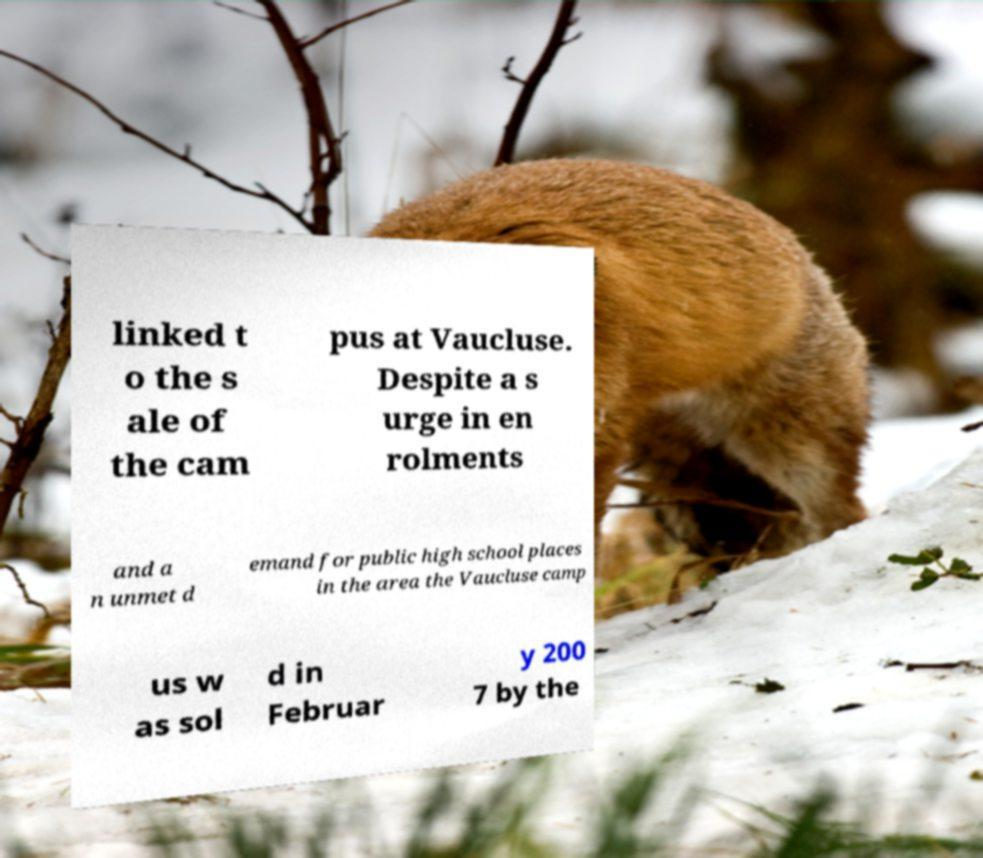Could you extract and type out the text from this image? linked t o the s ale of the cam pus at Vaucluse. Despite a s urge in en rolments and a n unmet d emand for public high school places in the area the Vaucluse camp us w as sol d in Februar y 200 7 by the 